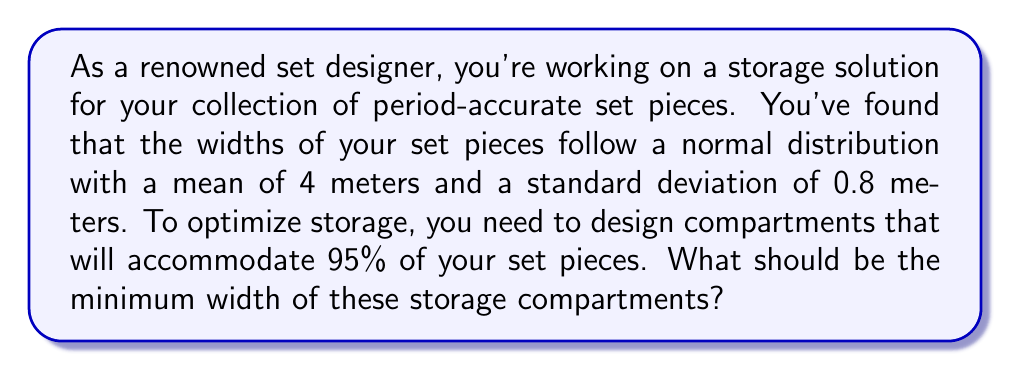Could you help me with this problem? To solve this problem, we need to use the properties of the normal distribution and the concept of z-scores.

1) We're given that the set piece widths follow a normal distribution with:
   $\mu = 4$ meters (mean)
   $\sigma = 0.8$ meters (standard deviation)

2) We want to find the width that will accommodate 95% of the set pieces. This means we're looking for the 97.5th percentile (as 2.5% will be larger than this width).

3) For a normal distribution, the 97.5th percentile corresponds to a z-score of 1.96.

4) The formula for converting a z-score to an x-value is:
   $$x = \mu + z\sigma$$

5) Substituting our values:
   $$x = 4 + (1.96 \times 0.8)$$

6) Calculating:
   $$x = 4 + 1.568 = 5.568$$ meters

Therefore, the minimum width of the storage compartments should be 5.568 meters to accommodate 95% of the set pieces.
Answer: 5.568 meters 